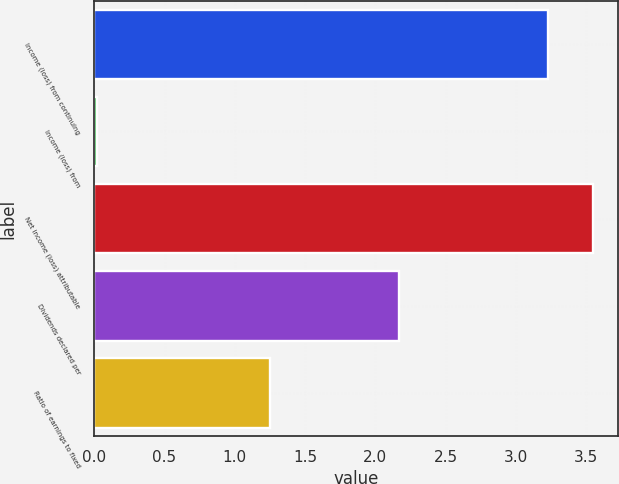Convert chart to OTSL. <chart><loc_0><loc_0><loc_500><loc_500><bar_chart><fcel>Income (loss) from continuing<fcel>Income (loss) from<fcel>Net income (loss) attributable<fcel>Dividends declared per<fcel>Ratio of earnings to fixed<nl><fcel>3.23<fcel>0.02<fcel>3.55<fcel>2.17<fcel>1.25<nl></chart> 